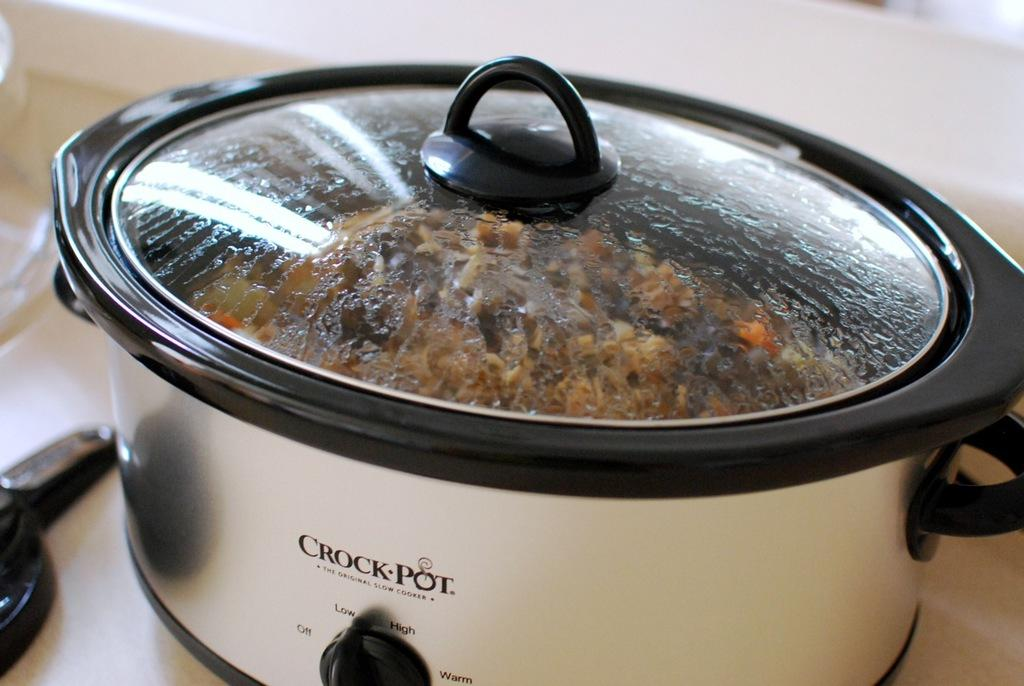<image>
Offer a succinct explanation of the picture presented. A Crock Pot that claims to be the original brand of slow cookers, has condensation covering the inside of the lid because it is cooking something. 